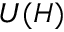<formula> <loc_0><loc_0><loc_500><loc_500>U ( H )</formula> 